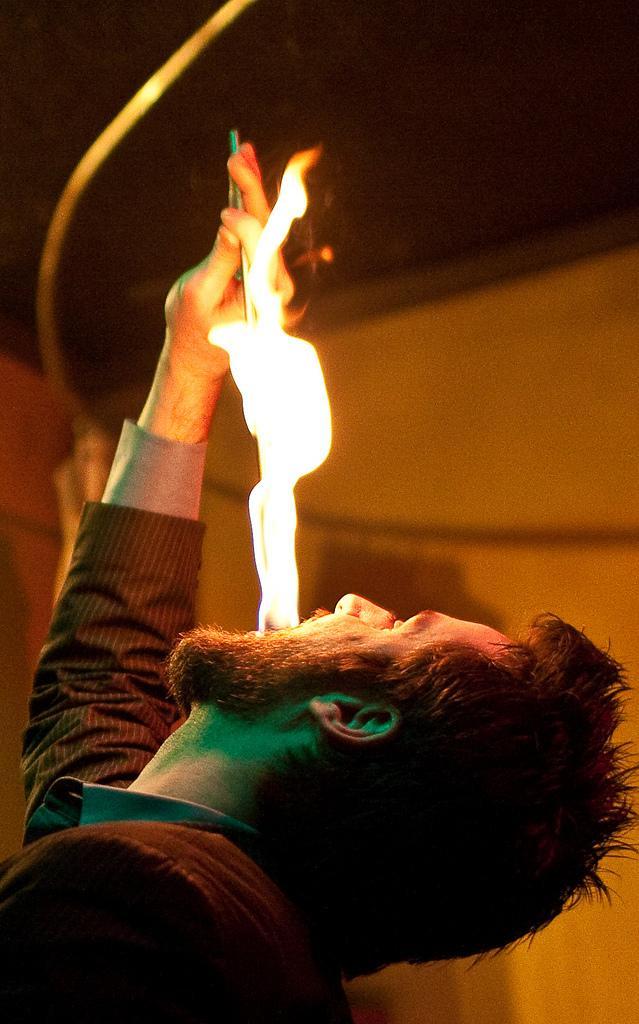Please provide a concise description of this image. A man is having fire from the mouth. 